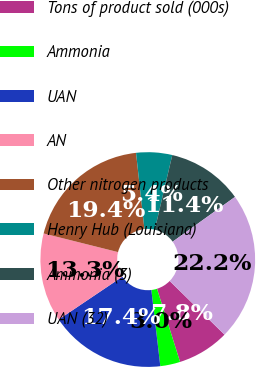Convert chart. <chart><loc_0><loc_0><loc_500><loc_500><pie_chart><fcel>Tons of product sold (000s)<fcel>Ammonia<fcel>UAN<fcel>AN<fcel>Other nitrogen products<fcel>Henry Hub (Louisiana)<fcel>Ammonia (3)<fcel>UAN (32)<nl><fcel>7.81%<fcel>3.0%<fcel>17.43%<fcel>13.34%<fcel>19.35%<fcel>5.41%<fcel>11.42%<fcel>22.24%<nl></chart> 